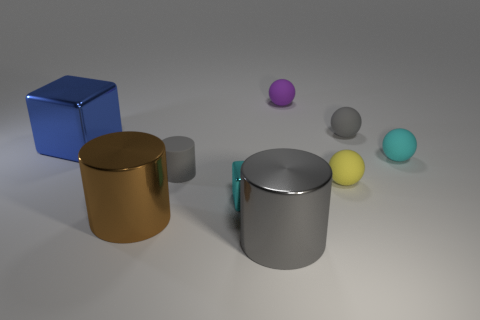Subtract all green cubes. How many gray cylinders are left? 2 Subtract all metal cylinders. How many cylinders are left? 1 Add 1 large shiny blocks. How many objects exist? 10 Subtract 1 blocks. How many blocks are left? 1 Subtract all purple spheres. How many spheres are left? 3 Subtract all cylinders. How many objects are left? 6 Subtract all red cylinders. Subtract all brown blocks. How many cylinders are left? 3 Subtract all tiny purple objects. Subtract all big cubes. How many objects are left? 7 Add 2 yellow matte balls. How many yellow matte balls are left? 3 Add 3 brown metal cylinders. How many brown metal cylinders exist? 4 